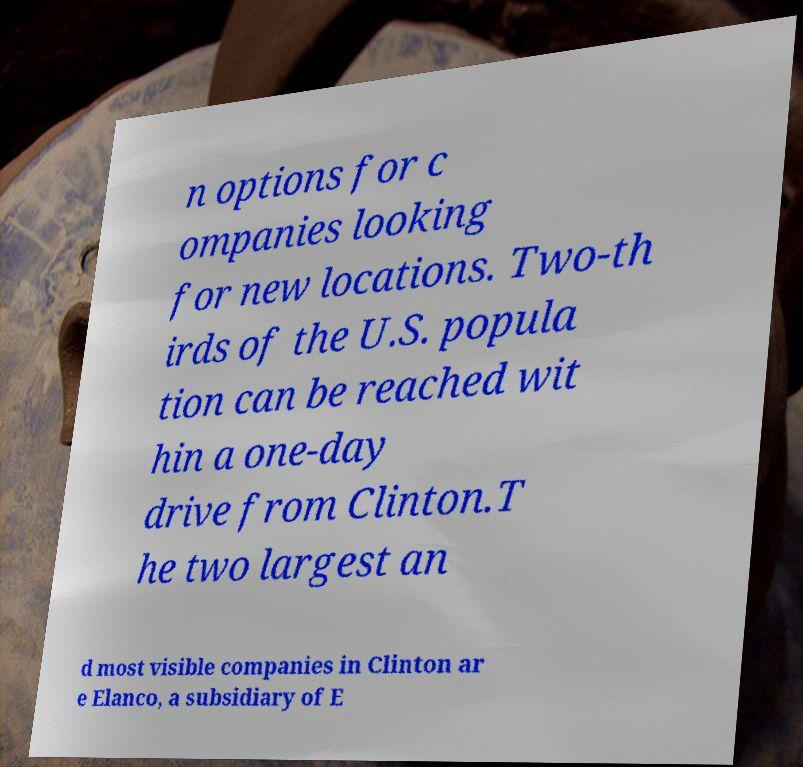I need the written content from this picture converted into text. Can you do that? n options for c ompanies looking for new locations. Two-th irds of the U.S. popula tion can be reached wit hin a one-day drive from Clinton.T he two largest an d most visible companies in Clinton ar e Elanco, a subsidiary of E 